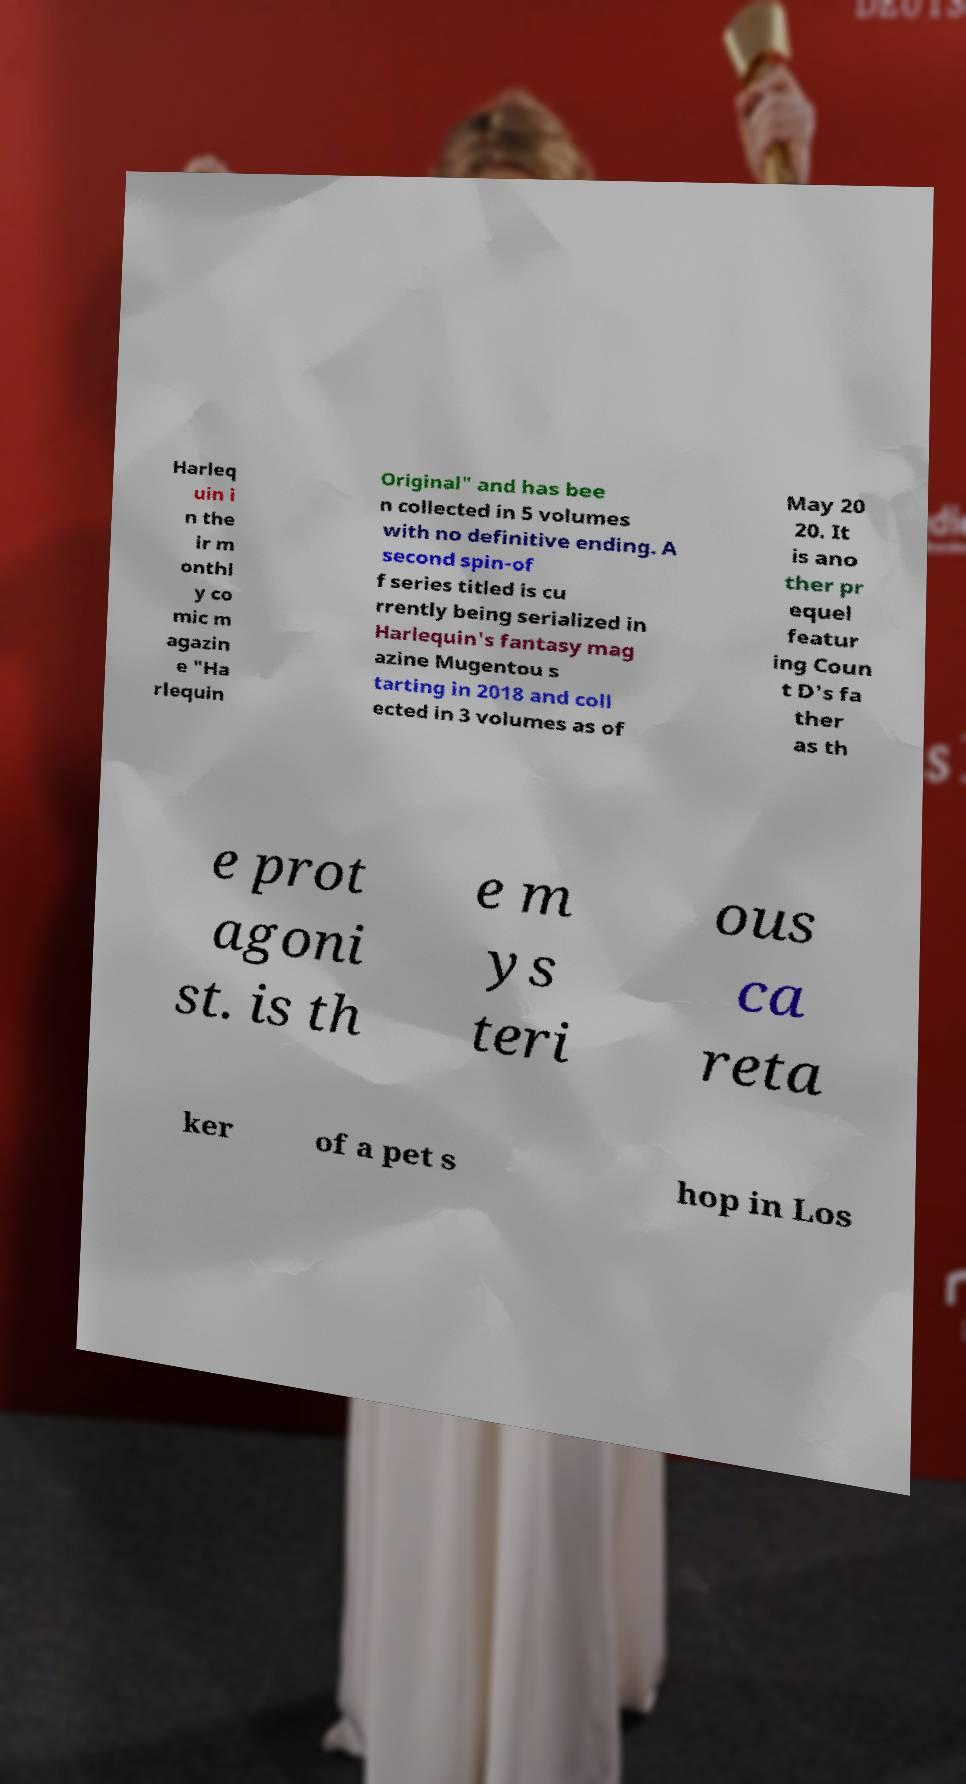Could you assist in decoding the text presented in this image and type it out clearly? Harleq uin i n the ir m onthl y co mic m agazin e "Ha rlequin Original" and has bee n collected in 5 volumes with no definitive ending. A second spin-of f series titled is cu rrently being serialized in Harlequin's fantasy mag azine Mugentou s tarting in 2018 and coll ected in 3 volumes as of May 20 20. It is ano ther pr equel featur ing Coun t D's fa ther as th e prot agoni st. is th e m ys teri ous ca reta ker of a pet s hop in Los 